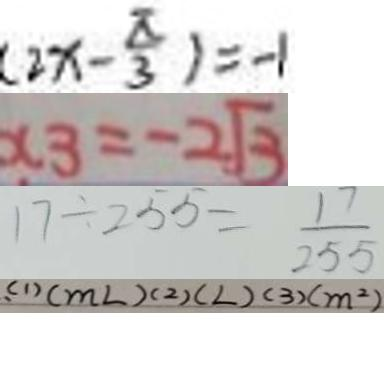Convert formula to latex. <formula><loc_0><loc_0><loc_500><loc_500>( 2 x - \frac { \pi } { 3 } ) = - 1 
 x _ { 3 } = - 2 \sqrt { 3 } 
 1 7 \div 2 5 5 = \frac { 1 7 } { 2 5 5 } 
 , ( 1 ) ( m L ) ( 2 ) ( L ) ( 3 ) ( m ^ { 2 } )</formula> 